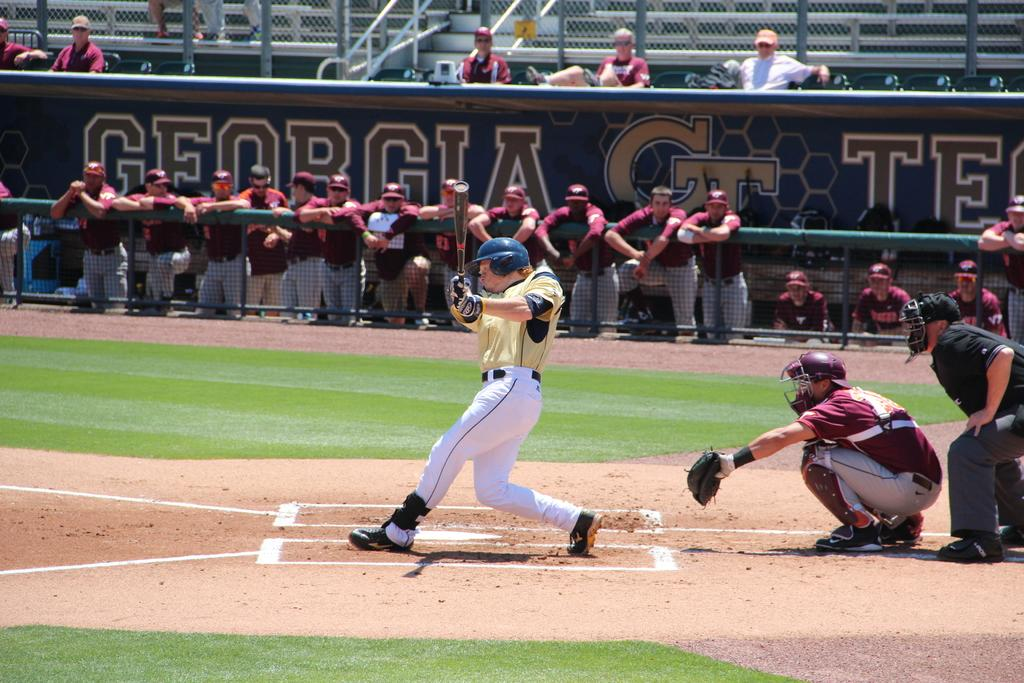<image>
Share a concise interpretation of the image provided. A baseball player is swinging at a pitch and the stadium walls say Georgia. 